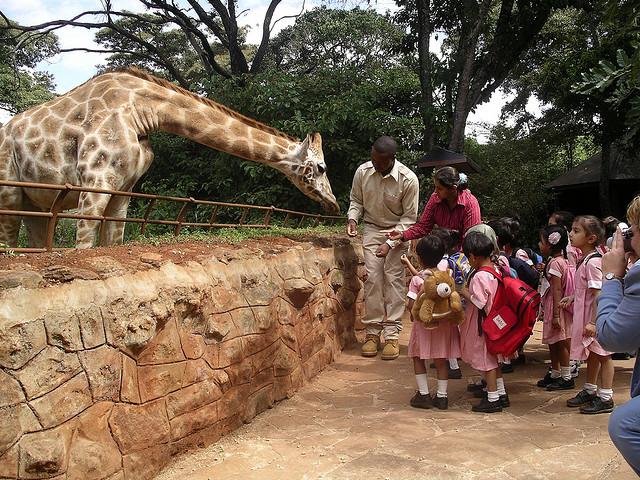Is this a zoo?
Keep it brief. Yes. What color backpack does the girl have?
Give a very brief answer. Red. Are the children wearing matching clothes?
Write a very short answer. Yes. 